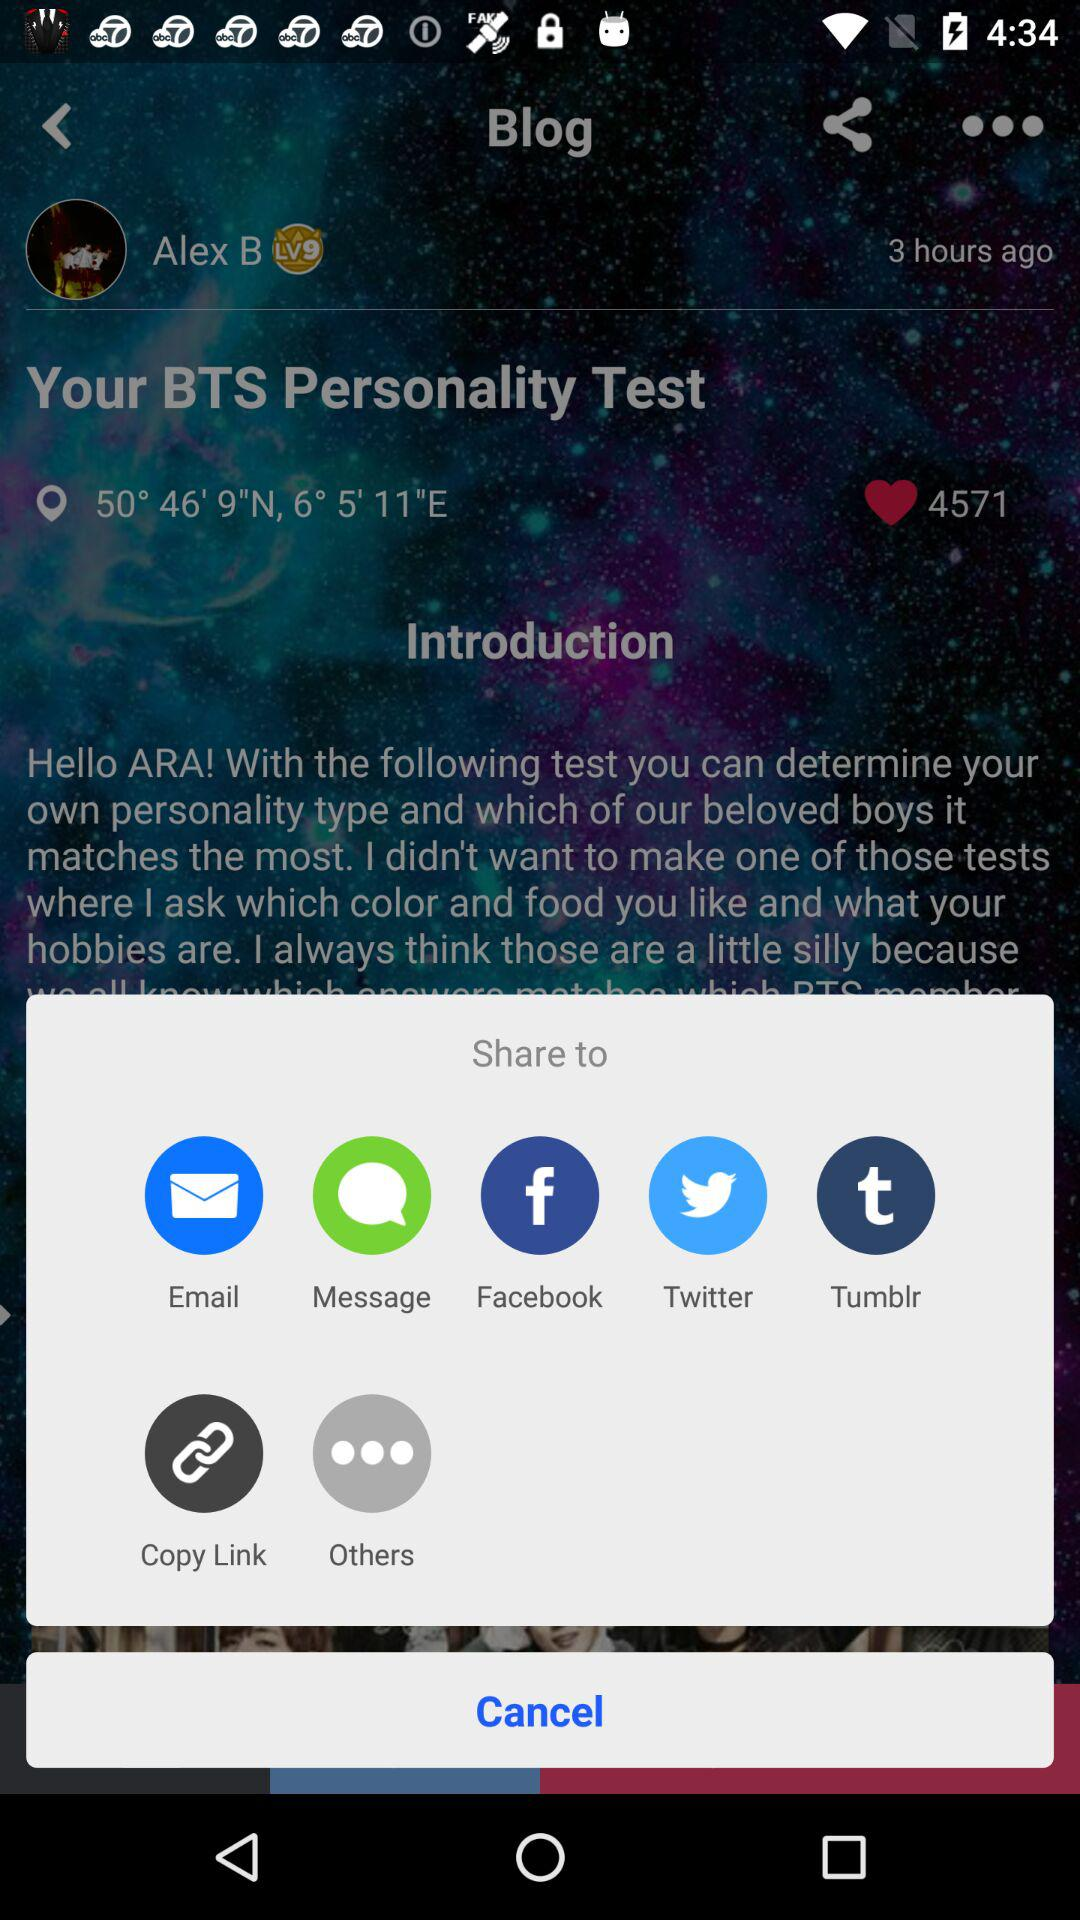How many likes on the BTS personality test? There are 4571 likes. 